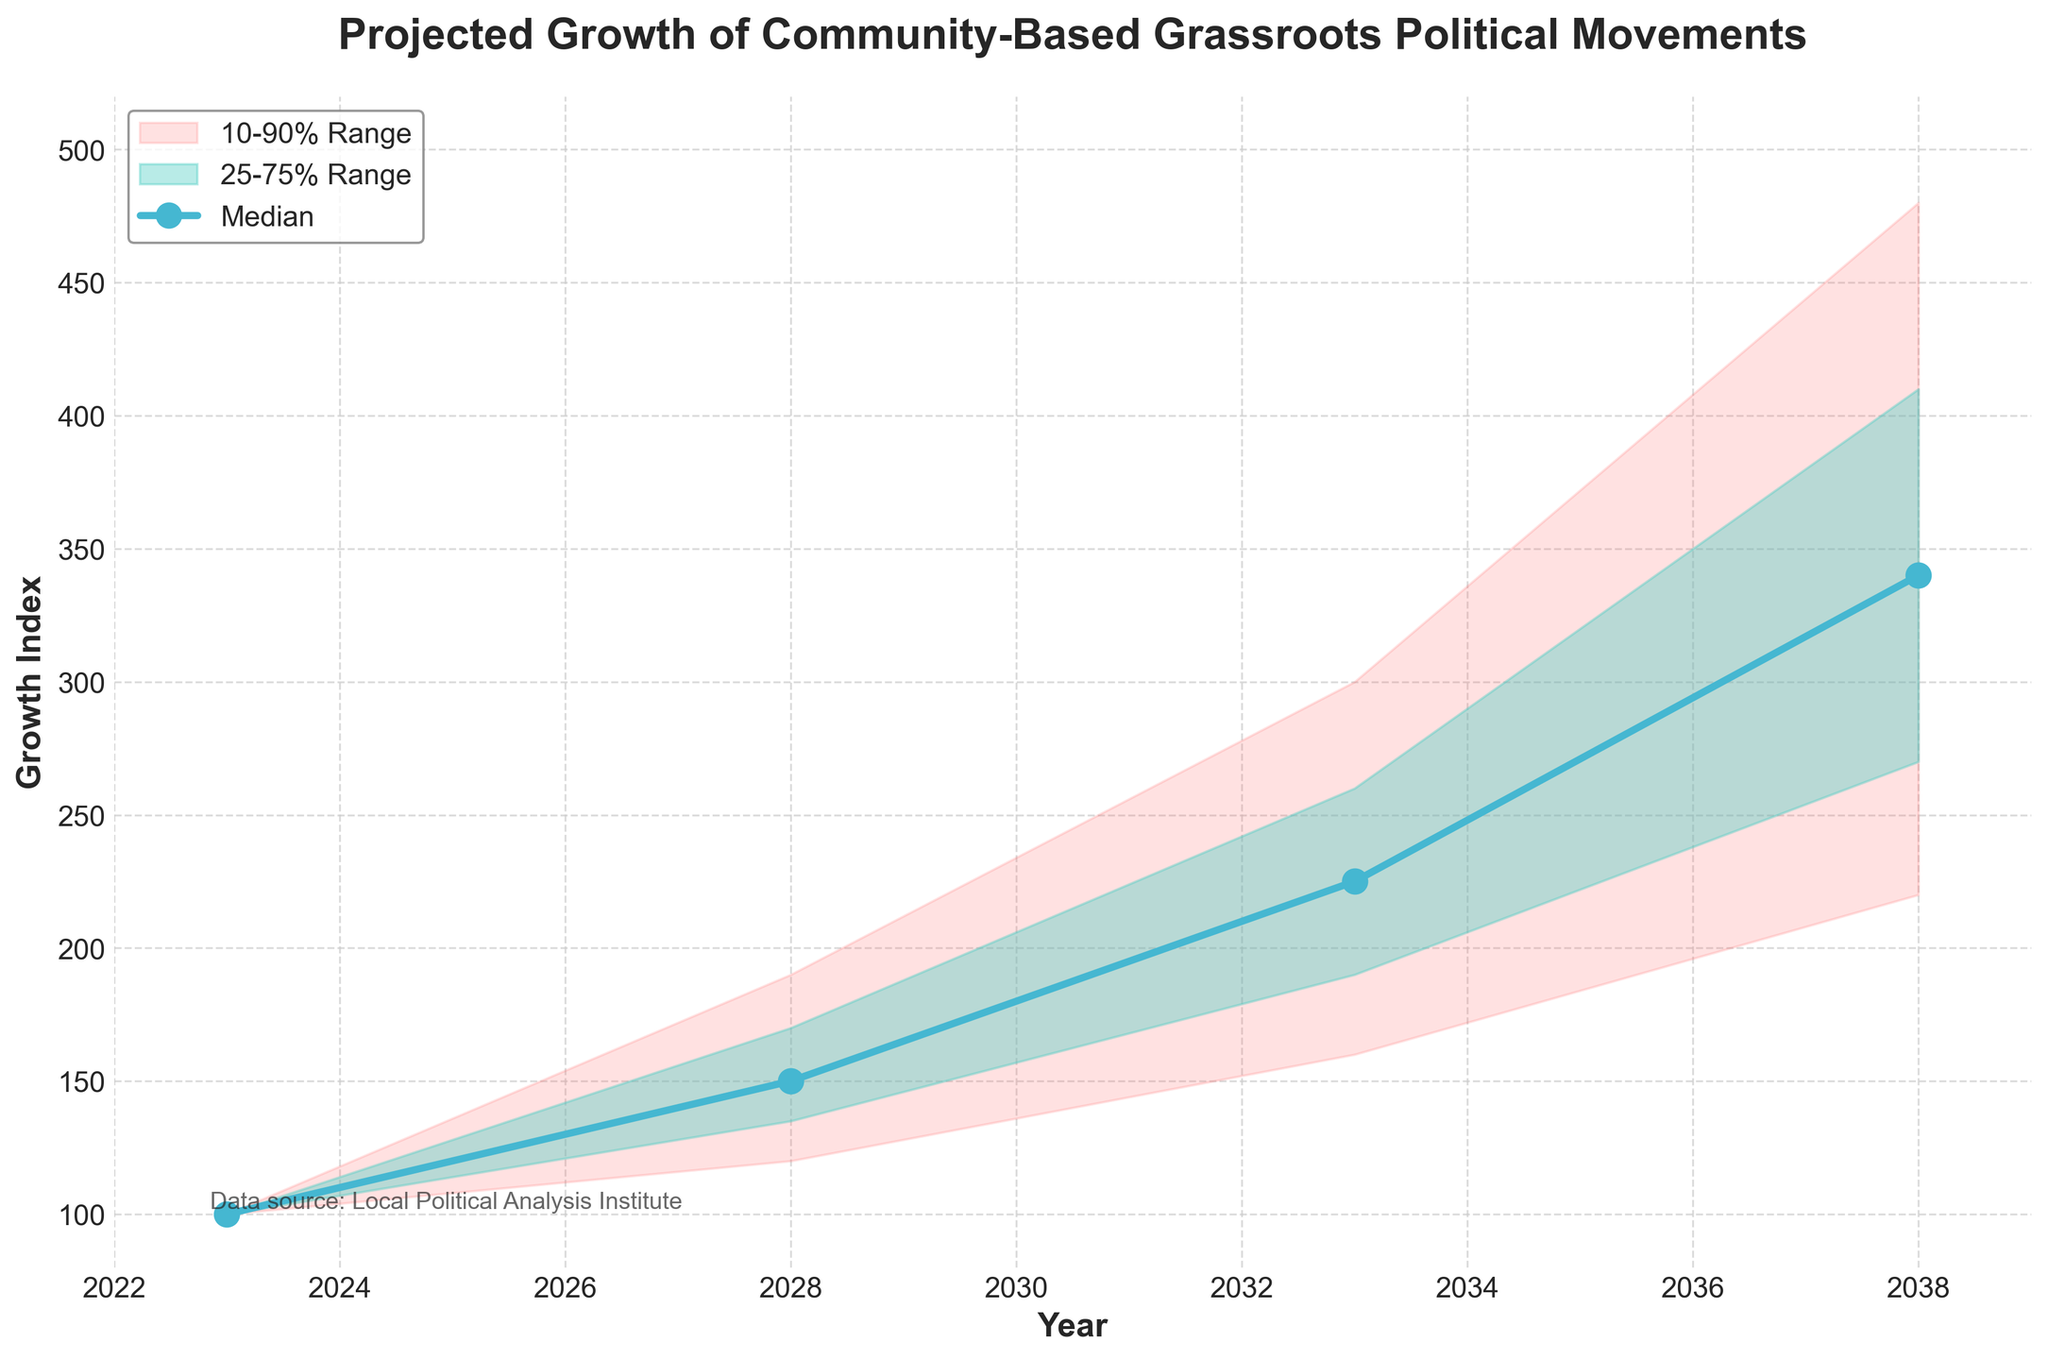What's the title of the figure? The title is clearly labeled at the top of the chart.
Answer: Projected Growth of Community-Based Grassroots Political Movements What is the median growth index projected for 2033? The median value is represented by the line and is also labeled in the dataset under the year 2033.
Answer: 225 In which year does the upper 90% projection reach 480? Looking at the upper 90% line and finding the corresponding year when it reaches 480.
Answer: 2038 By how much does the median growth index increase from 2028 to 2038? The median values for 2028 and 2038 are 150 and 340 respectively. The increase is 340 - 150.
Answer: 190 What is the range of growth index values within the 25-75% range for the year 2028? The upper 75% and lower 25% values for 2028 are 170 and 135 respectively. The range is 170 - 135.
Answer: 35 Compare the Upper 90% interval in 2033 and 2028. Which year has a higher upper 90% value, and by how much? The upper 90% values for 2033 and 2028 are 300 and 190, respectively. The difference is 300 - 190.
Answer: 2033 by 110 What is the most significant change projected in the lower 10% growth index? Looking at the lower 10% values over the years (100, 120, 160, 220), the largest change is 220 - 100.
Answer: 120 By what factor is the median growth index expected to increase from 2023 to 2038? The median growth index for 2023 is 100, and for 2038 it is 340. The factor is 340 / 100.
Answer: 3.4 How wide is the projected 10-90% range in 2038? The upper 90% and lower 10% values for 2038 are 480 and 220, respectively. The range is 480 - 220.
Answer: 260 